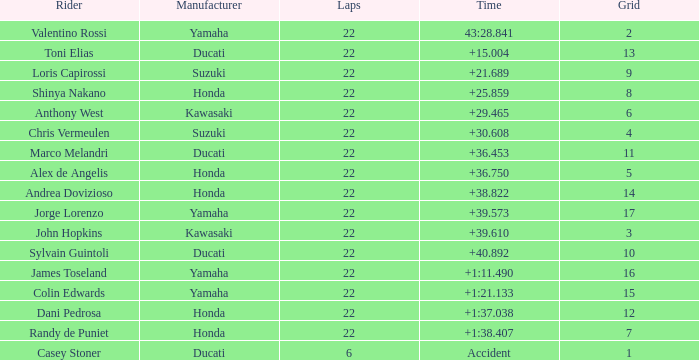What is honda's top grid position with a time of +1:3 7.0. 